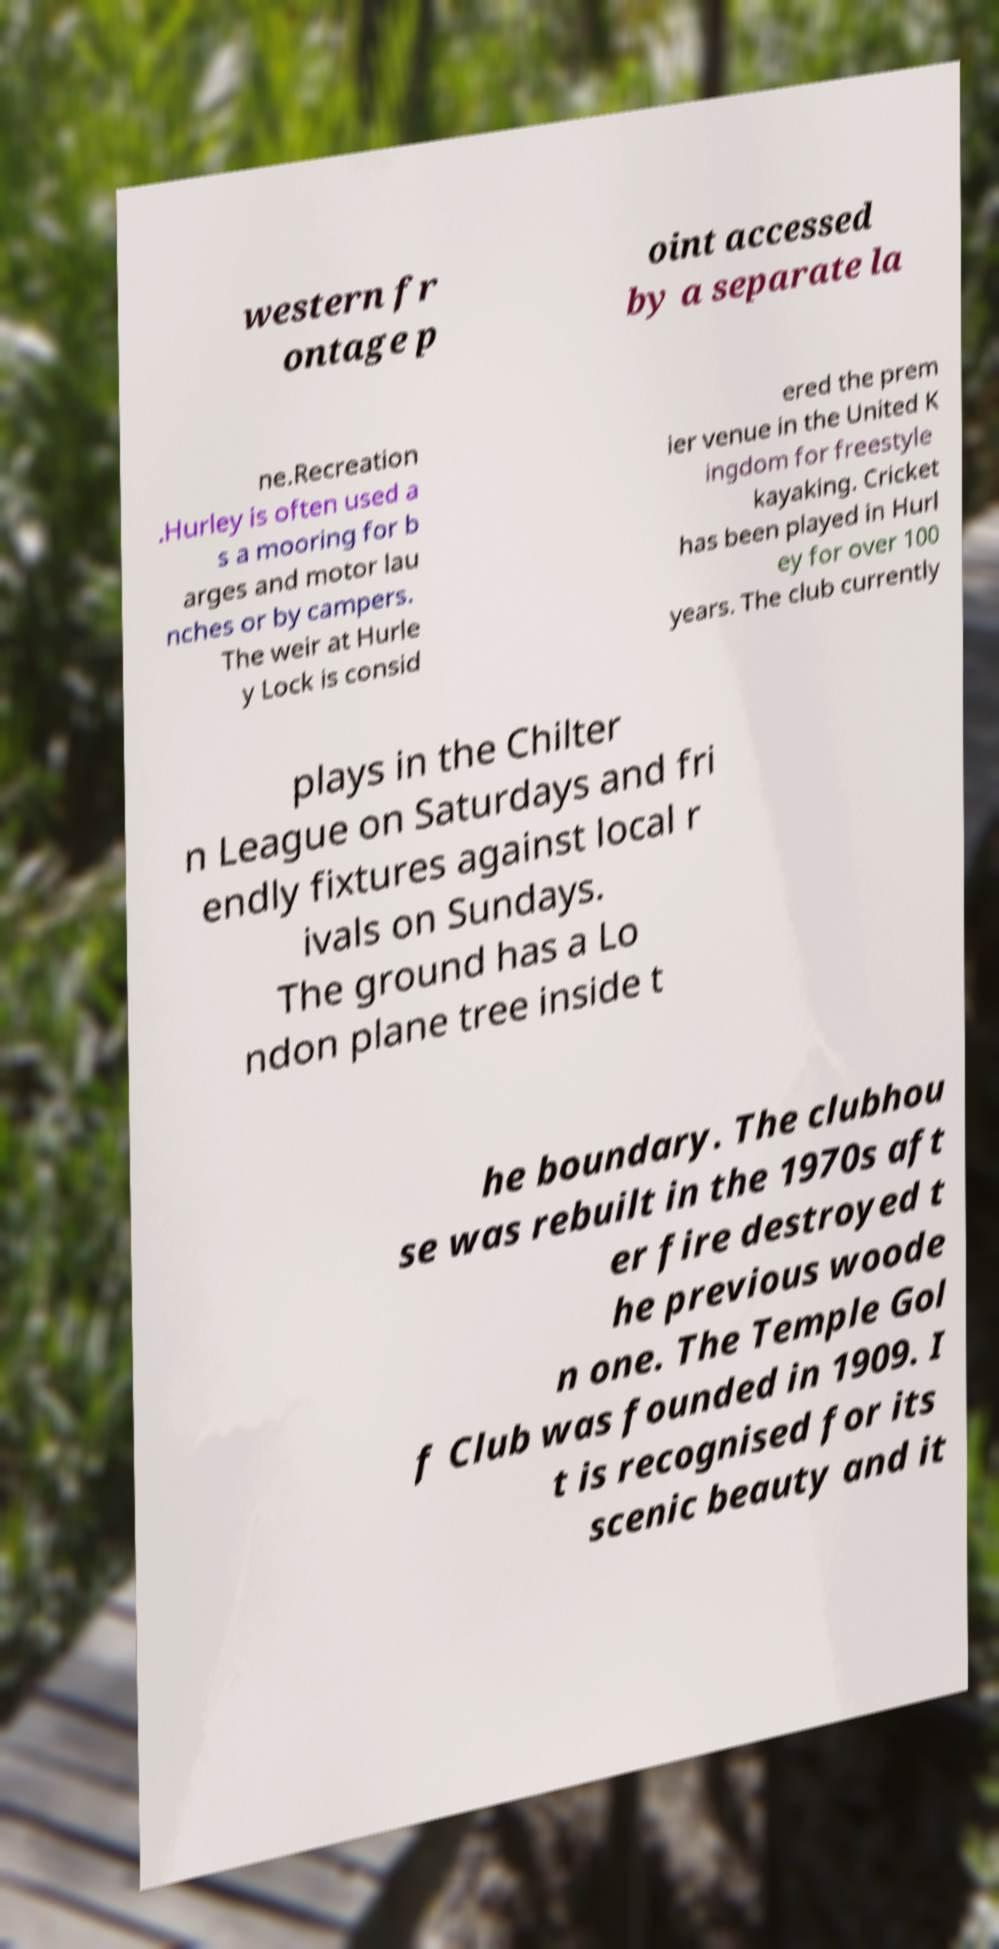Could you assist in decoding the text presented in this image and type it out clearly? western fr ontage p oint accessed by a separate la ne.Recreation .Hurley is often used a s a mooring for b arges and motor lau nches or by campers. The weir at Hurle y Lock is consid ered the prem ier venue in the United K ingdom for freestyle kayaking. Cricket has been played in Hurl ey for over 100 years. The club currently plays in the Chilter n League on Saturdays and fri endly fixtures against local r ivals on Sundays. The ground has a Lo ndon plane tree inside t he boundary. The clubhou se was rebuilt in the 1970s aft er fire destroyed t he previous woode n one. The Temple Gol f Club was founded in 1909. I t is recognised for its scenic beauty and it 